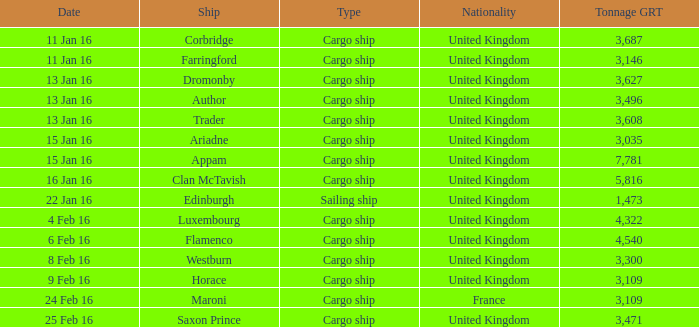Can you provide the grt (gross registered tonnage) for the ship called author? 3496.0. 